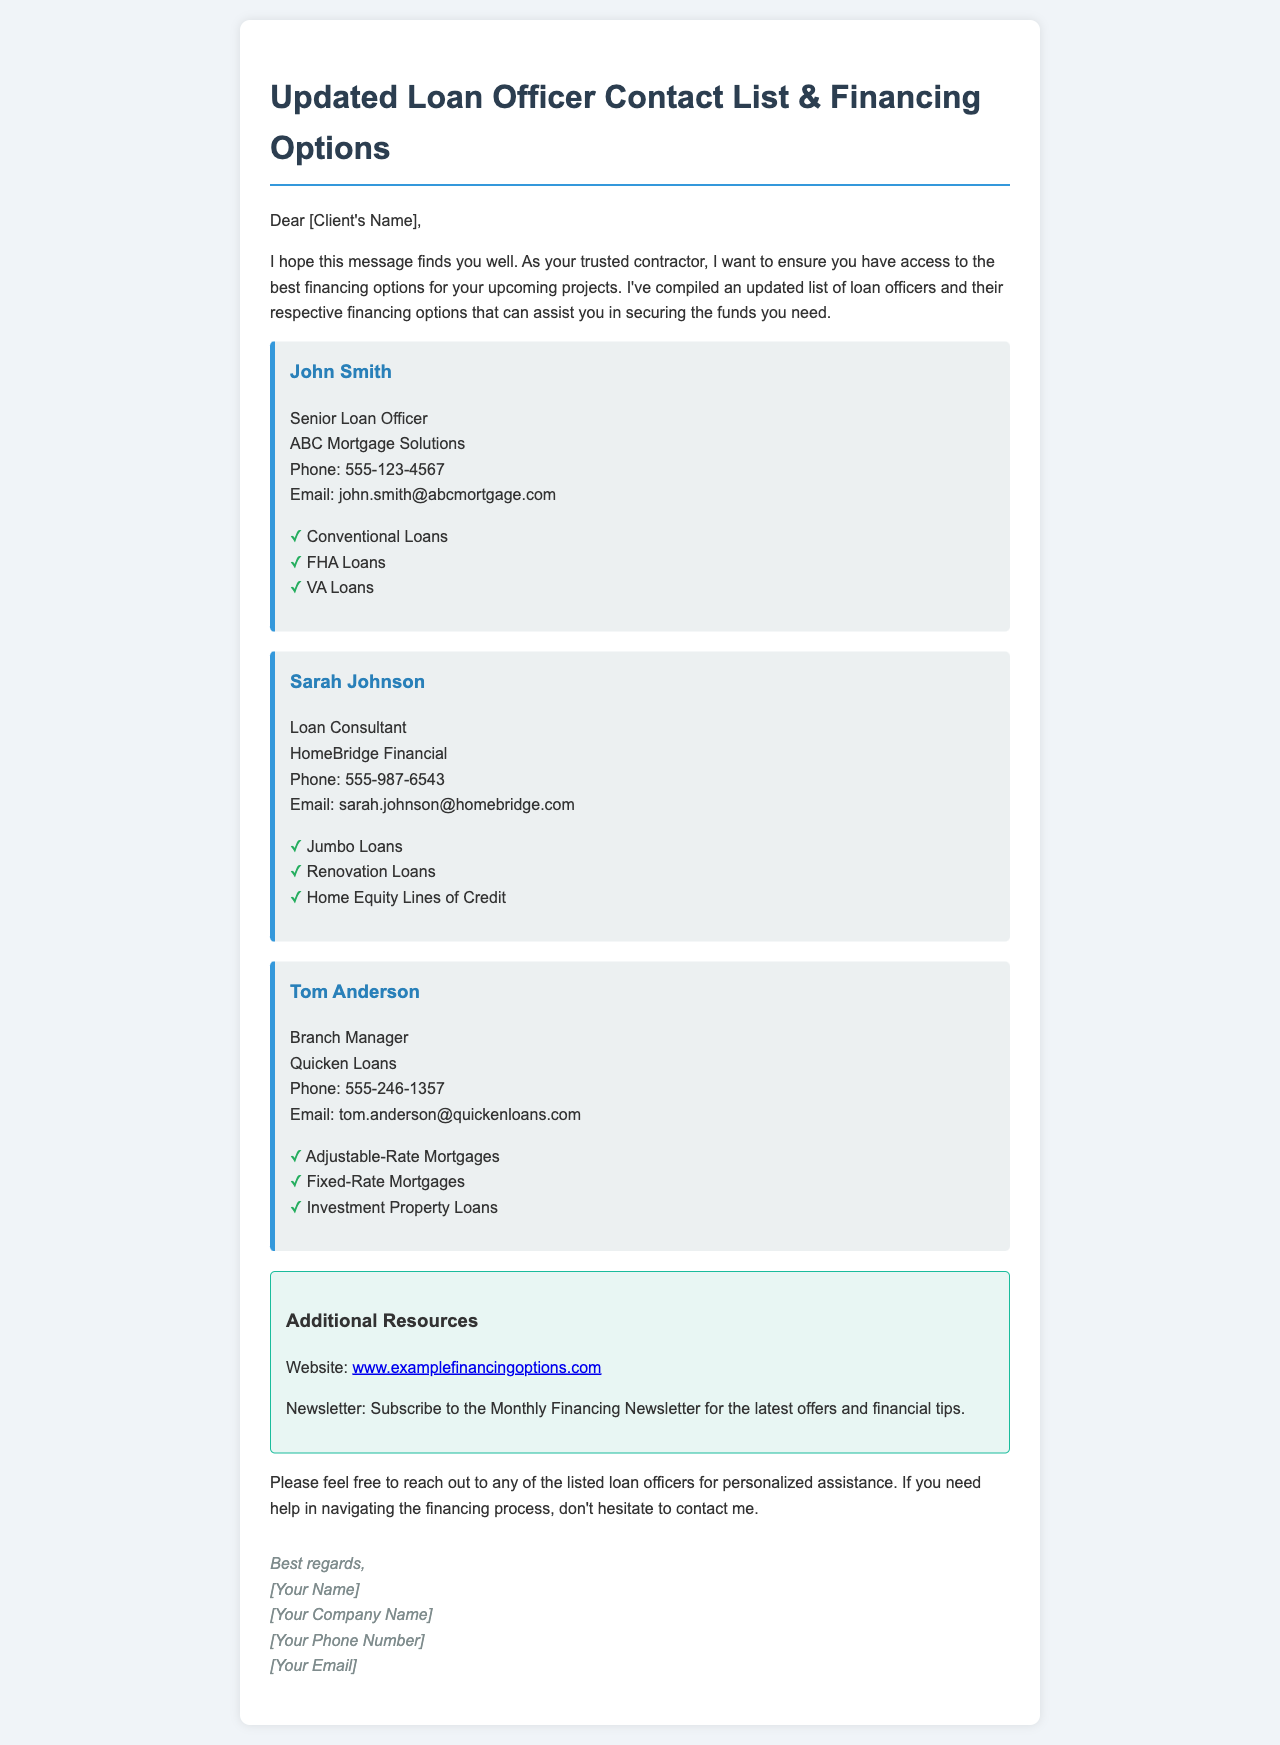What is the title of the document? The title is clearly stated at the top of the document and summarizes its purpose.
Answer: Updated Loan Officer Contact List & Financing Options Who is the Senior Loan Officer? This information is provided in the section dedicated to loan officers, specifically mentioning their title and name.
Answer: John Smith What types of loans does John Smith offer? The document lists the types of loans available under each loan officer's name.
Answer: Conventional Loans, FHA Loans, VA Loans What is the phone number for Sarah Johnson? The phone number is included in the contact information for each loan officer.
Answer: 555-987-6543 Which financial option does Tom Anderson provide? The document specifies the loan options available for each officer, mentioning what Tom offers.
Answer: Adjustable-Rate Mortgages, Fixed-Rate Mortgages, Investment Property Loans What organization does Sarah Johnson work for? This is indicated in the section about Sarah Johnson along with her title and contact details.
Answer: HomeBridge Financial How can clients subscribe to financial news? The document states this in the Additional Resources section, indicating how clients can stay updated.
Answer: Subscribe to the Monthly Financing Newsletter What is the website mentioned for additional resources? The document explicitly lists a URL for clients seeking more information on financing options.
Answer: www.examplefinancingoptions.com What should clients do if they need help with financing? The document suggests a course of action if clients are unsure about the financing process.
Answer: Contact me 